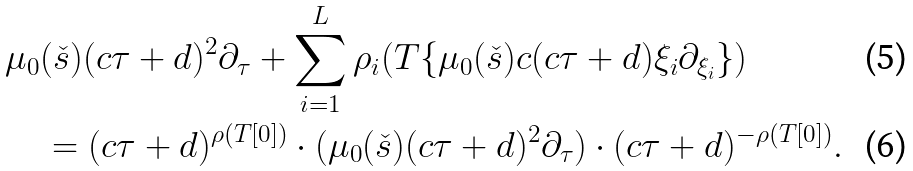Convert formula to latex. <formula><loc_0><loc_0><loc_500><loc_500>& \mu _ { 0 } ( \check { s } ) ( c \tau + d ) ^ { 2 } \partial _ { \tau } + \sum _ { i = 1 } ^ { L } \rho _ { i } ( T \{ \mu _ { 0 } ( \check { s } ) c ( c \tau + d ) \xi _ { i } \partial _ { \xi _ { i } } \} ) \\ & \quad = ( c \tau + d ) ^ { \rho ( T [ 0 ] ) } \cdot ( \mu _ { 0 } ( \check { s } ) ( c \tau + d ) ^ { 2 } \partial _ { \tau } ) \cdot ( c \tau + d ) ^ { - \rho ( T [ 0 ] ) } .</formula> 